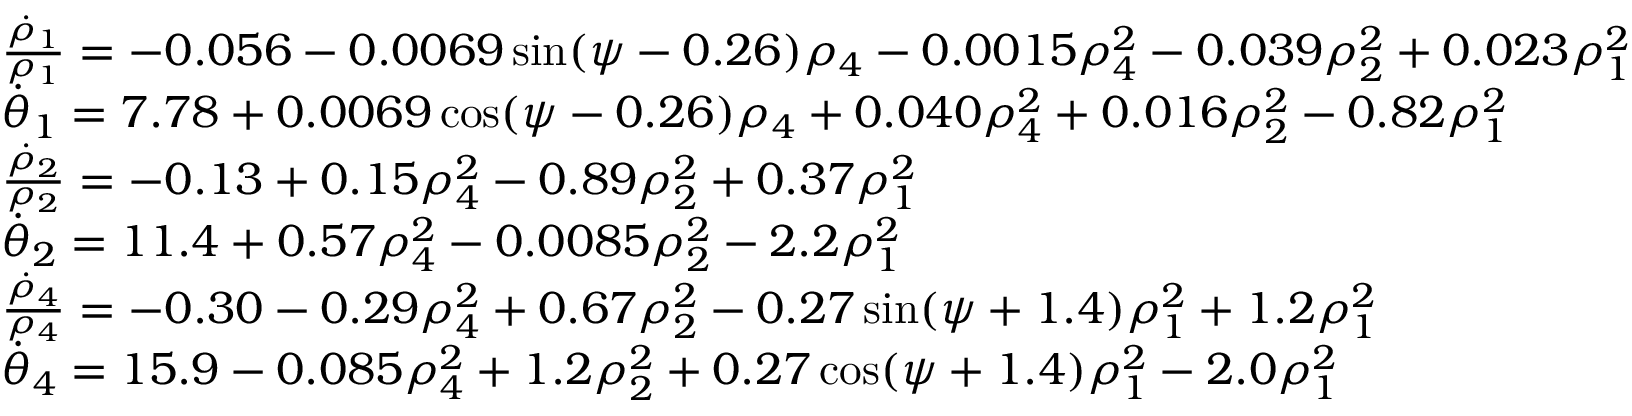<formula> <loc_0><loc_0><loc_500><loc_500>\begin{array} { l } { \frac { \dot { \rho } _ { 1 } } { \rho _ { 1 } } = - 0 . 0 5 6 - 0 . 0 0 6 9 \sin ( \psi - 0 . 2 6 ) \rho _ { 4 } - 0 . 0 0 1 5 \rho _ { 4 } ^ { 2 } - 0 . 0 3 9 \rho _ { 2 } ^ { 2 } + 0 . 0 2 3 \rho _ { 1 } ^ { 2 } } \\ { \dot { \theta } _ { 1 } = 7 . 7 8 + 0 . 0 0 6 9 \cos ( \psi - 0 . 2 6 ) \rho _ { 4 } + 0 . 0 4 0 \rho _ { 4 } ^ { 2 } + 0 . 0 1 6 \rho _ { 2 } ^ { 2 } - 0 . 8 2 \rho _ { 1 } ^ { 2 } } \\ { \frac { \dot { \rho } _ { 2 } } { \rho _ { 2 } } = - 0 . 1 3 + 0 . 1 5 \rho _ { 4 } ^ { 2 } - 0 . 8 9 \rho _ { 2 } ^ { 2 } + 0 . 3 7 \rho _ { 1 } ^ { 2 } } \\ { \dot { \theta } _ { 2 } = 1 1 . 4 + 0 . 5 7 \rho _ { 4 } ^ { 2 } - 0 . 0 0 8 5 \rho _ { 2 } ^ { 2 } - 2 . 2 \rho _ { 1 } ^ { 2 } } \\ { \frac { \dot { \rho } _ { 4 } } { \rho _ { 4 } } = - 0 . 3 0 - 0 . 2 9 \rho _ { 4 } ^ { 2 } + 0 . 6 7 \rho _ { 2 } ^ { 2 } - 0 . 2 7 \sin ( \psi + 1 . 4 ) \rho _ { 1 } ^ { 2 } + 1 . 2 \rho _ { 1 } ^ { 2 } } \\ { \dot { \theta } _ { 4 } = 1 5 . 9 - 0 . 0 8 5 \rho _ { 4 } ^ { 2 } + 1 . 2 \rho _ { 2 } ^ { 2 } + 0 . 2 7 \cos ( \psi + 1 . 4 ) \rho _ { 1 } ^ { 2 } - 2 . 0 \rho _ { 1 } ^ { 2 } } \end{array}</formula> 